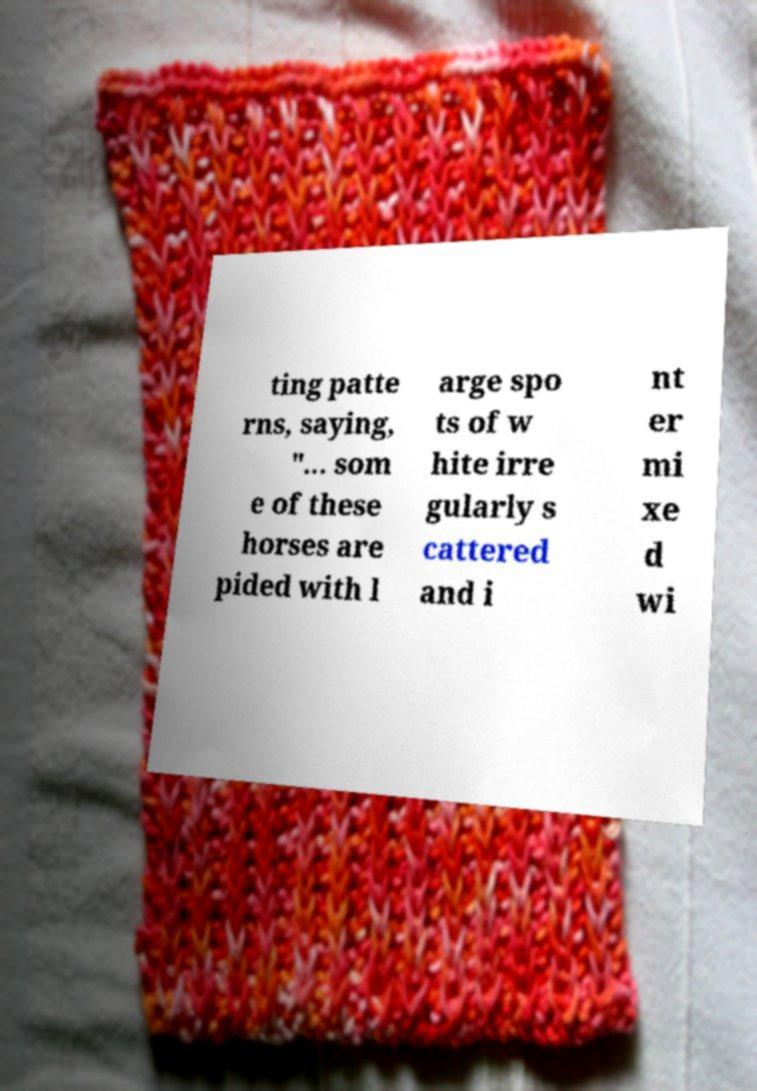Can you read and provide the text displayed in the image?This photo seems to have some interesting text. Can you extract and type it out for me? ting patte rns, saying, "... som e of these horses are pided with l arge spo ts of w hite irre gularly s cattered and i nt er mi xe d wi 